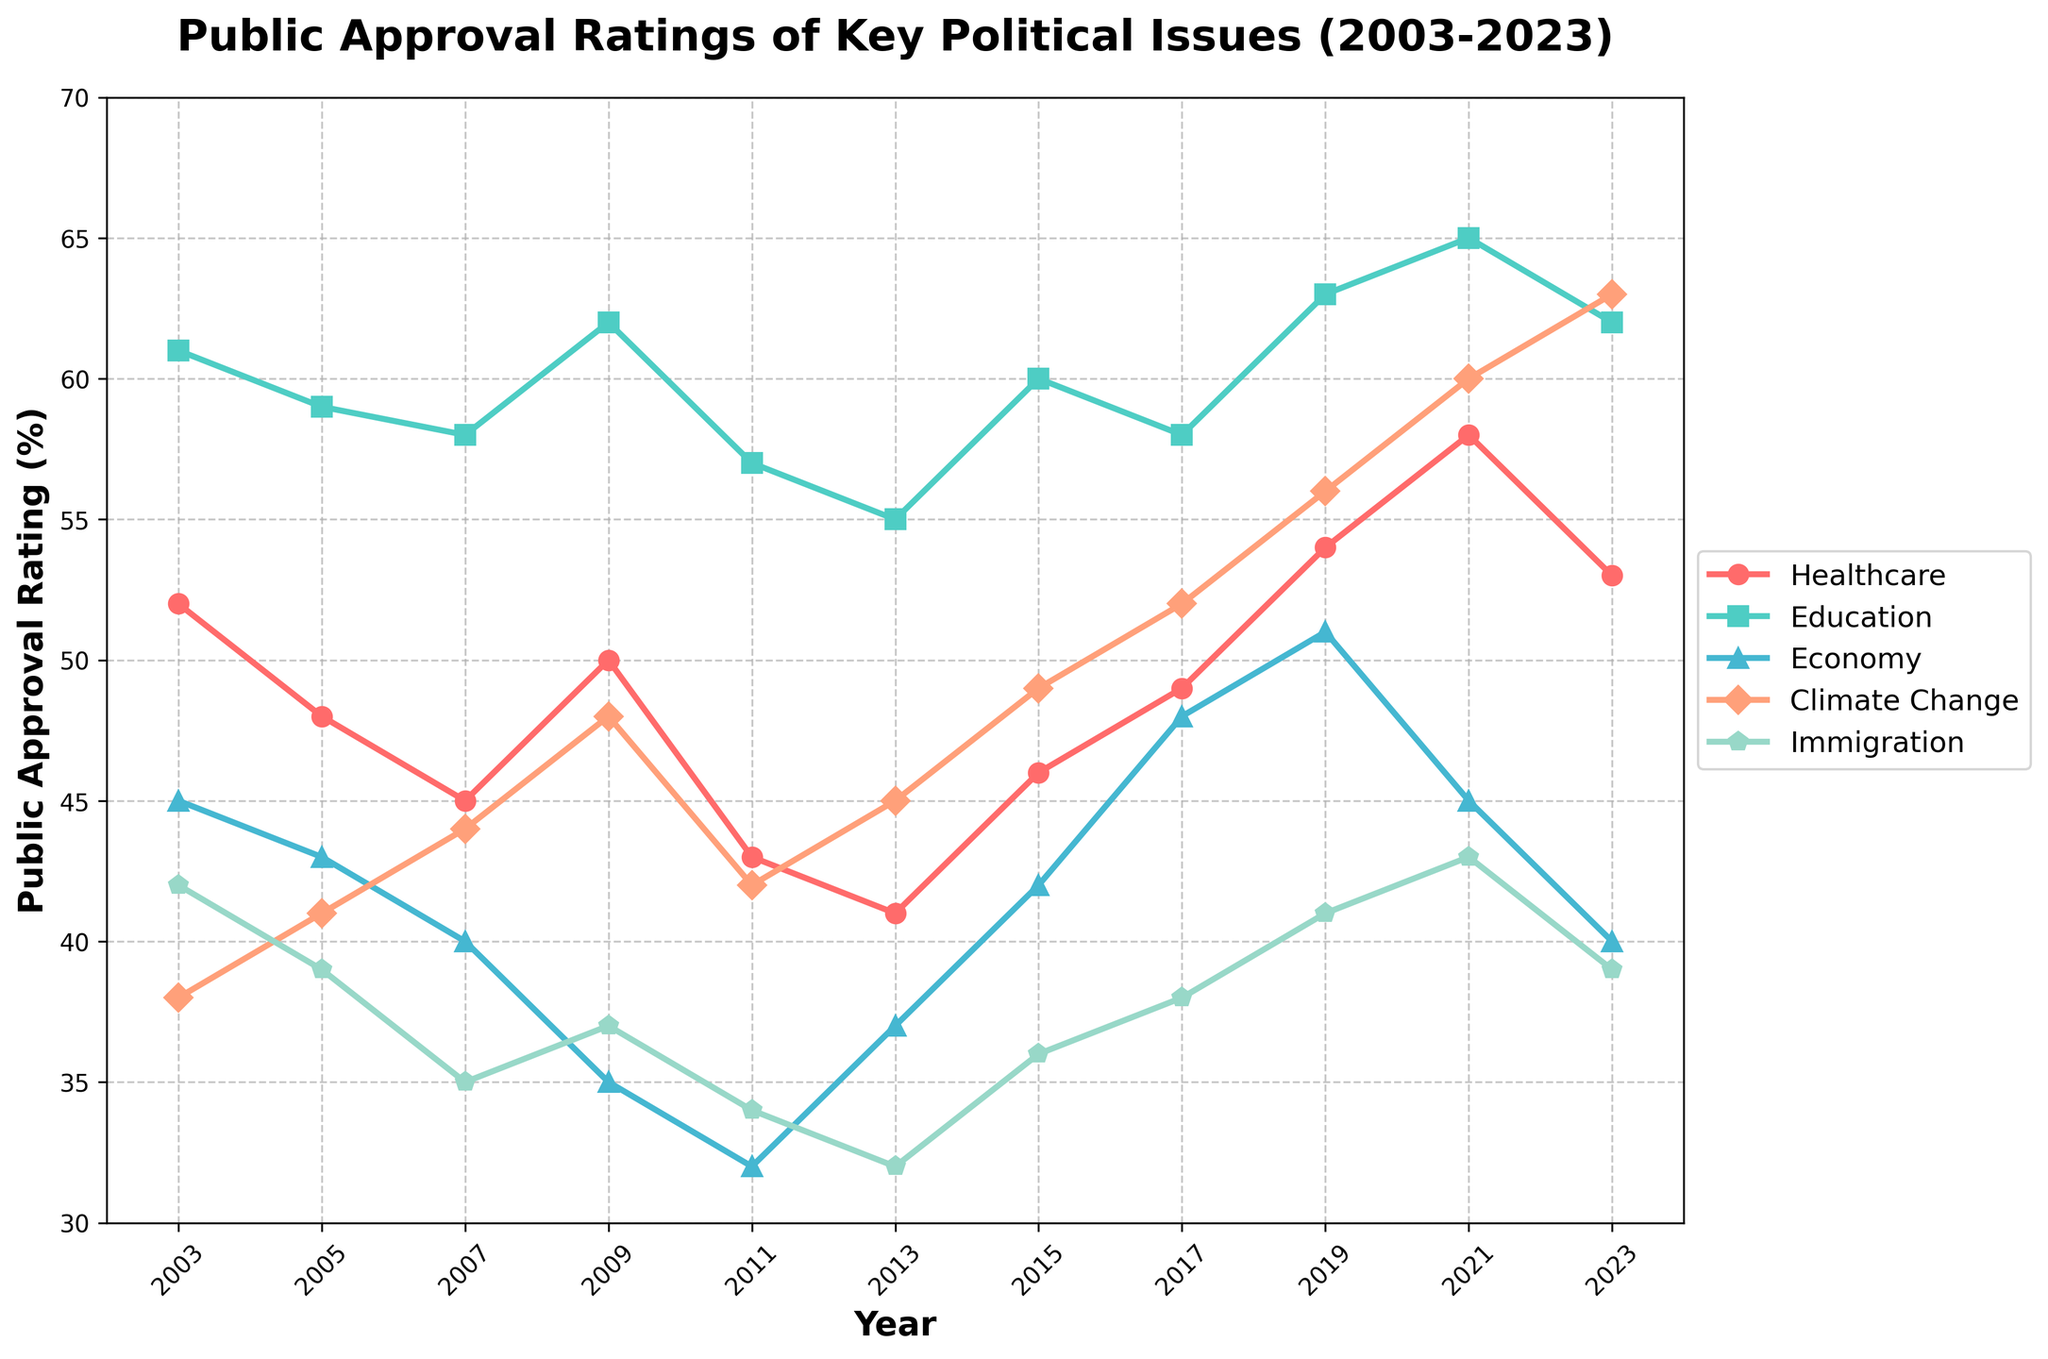What year saw the highest approval rating for climate change? By looking at the graph, we find the peak point on the Climate Change line, which occurs in 2023 with an approval rating of 63%.
Answer: 2023 In which year was the approval rating for immigration the lowest, and what was the rating? Examining the graph, we locate the lowest point on the Immigration line, which occurs in 2013 with an approval rating of 32%.
Answer: 2013, 32% Between 2009 and 2023, how much did the approval rating for the economy change? Identifying the points corresponding to the years 2009 and 2023 on the Economy line, we see it starts at 35% in 2009 and ends at 40% in 2023. The change is 40% - 35% = 5%.
Answer: 5% Which issue had the highest average approval rating over the two decades? We need to find the average rating for each issue by summing their values and dividing by the number of data points. Healthcare: (52+48+45+50+43+41+46+49+54+58+53)/11 = 49. Education: (61+59+58+62+57+55+60+58+63+65+62)/11 = 59. Economy: (45+43+40+35+32+37+42+48+51+45+40)/11 = 42. Climate Change: (38+41+44+48+42+45+49+52+56+60+63)/11 = 49. Immigration: (42+39+35+37+34+32+36+38+41+43+39)/11 = 37. The highest average value is for Education: 59%.
Answer: Education Which two years show the largest drop in the approval rating for healthcare? By observing the graph, we find two points that indicate the largest negative change between consecutive years on the Healthcare line. From 2003 to 2005, the rating drops from 52% to 48% which is a change of 4%. Other changes are smaller. Hence, 2003 to 2005 show the largest drop.
Answer: 2003-2005 How does the approval rating for climate change in 2023 compare to that in 2003? On the Climate Change line, we compare the beginning and ending points. In 2003, the rating is 38%, and in 2023, it is 63%. This shows an increase of 63% - 38% = 25%.
Answer: Higher by 25% What is the median approval rating for education between 2011 and 2021? Extract the ratings from the Education line for the years 2011, 2013, 2015, 2017, 2019, and 2021: 57, 55, 60, 58, 63, and 65. Arranging them in ascending order: 55, 57, 58, 60, 63, and 65. The median is the average of 58 and 60, which is (58 + 60) / 2 = 59.
Answer: 59 From 2005 to 2009, which political issue saw the largest increase in approval rating? We compare the changes for each issue from 2005 to 2009: Healthcare: 50 - 48 = 2. Education: 62 - 59 = 3. Economy: 35 - 43 = -8. Climate Change: 48 - 41 = 7. Immigration: 37 - 39 = -2. Climate Change saw the largest increase with a change of 7%.
Answer: Climate Change Across the entire time span, did the approval rating for any issue never surpass 50%? By inspecting the graph for the highest points in each issue, we see that the Economy never surpassed 51%, reaching its maximum at 51% in 2019. All other issues had ratings surpassing 50% at some point.
Answer: No, Economy never surpassed 51% In which year did both healthcare and education have their closest approval ratings, and what were the ratings? By observing the graph, we see that in 2017 Healthcare had a rating of 49% and Education had a rating of 58%. The difference is only 9%. This is the closest compared to other years where the gap is larger.
Answer: 2017, 49% Healthcare and 58% Education 